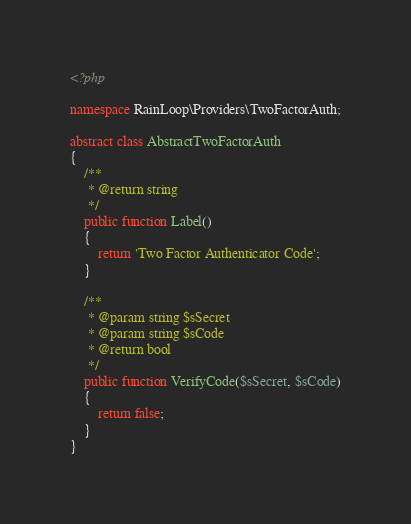Convert code to text. <code><loc_0><loc_0><loc_500><loc_500><_PHP_><?php

namespace RainLoop\Providers\TwoFactorAuth;

abstract class AbstractTwoFactorAuth
{
	/**
	 * @return string
	 */
	public function Label()
	{
		return 'Two Factor Authenticator Code';
	}
	
	/**
	 * @param string $sSecret
	 * @param string $sCode
	 * @return bool
	 */
	public function VerifyCode($sSecret, $sCode)
	{
		return false;
	}
}
</code> 